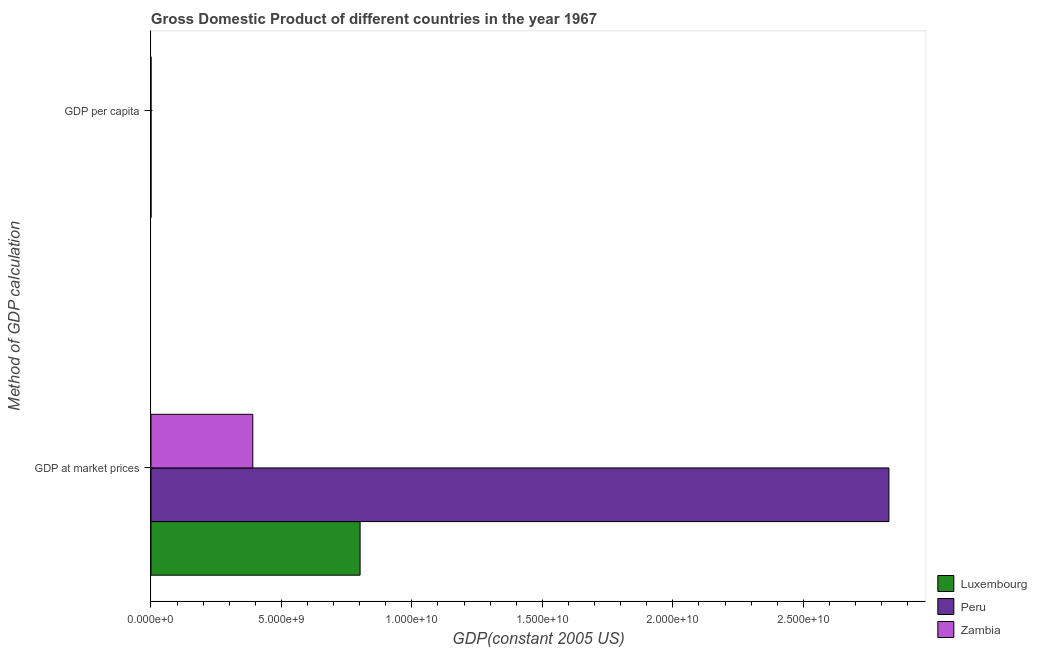How many different coloured bars are there?
Offer a very short reply. 3. How many bars are there on the 2nd tick from the bottom?
Provide a short and direct response. 3. What is the label of the 2nd group of bars from the top?
Give a very brief answer. GDP at market prices. What is the gdp at market prices in Zambia?
Keep it short and to the point. 3.90e+09. Across all countries, what is the maximum gdp per capita?
Provide a succinct answer. 2.39e+04. Across all countries, what is the minimum gdp at market prices?
Give a very brief answer. 3.90e+09. In which country was the gdp per capita maximum?
Give a very brief answer. Luxembourg. In which country was the gdp at market prices minimum?
Your answer should be very brief. Zambia. What is the total gdp per capita in the graph?
Your answer should be very brief. 2.73e+04. What is the difference between the gdp at market prices in Luxembourg and that in Peru?
Offer a very short reply. -2.03e+1. What is the difference between the gdp per capita in Zambia and the gdp at market prices in Luxembourg?
Make the answer very short. -8.01e+09. What is the average gdp at market prices per country?
Make the answer very short. 1.34e+1. What is the difference between the gdp per capita and gdp at market prices in Peru?
Ensure brevity in your answer.  -2.83e+1. In how many countries, is the gdp per capita greater than 11000000000 US$?
Make the answer very short. 0. What is the ratio of the gdp at market prices in Zambia to that in Luxembourg?
Your answer should be compact. 0.49. In how many countries, is the gdp per capita greater than the average gdp per capita taken over all countries?
Ensure brevity in your answer.  1. What does the 2nd bar from the top in GDP per capita represents?
Offer a very short reply. Peru. What does the 3rd bar from the bottom in GDP per capita represents?
Your response must be concise. Zambia. What is the difference between two consecutive major ticks on the X-axis?
Ensure brevity in your answer.  5.00e+09. Does the graph contain grids?
Provide a short and direct response. No. What is the title of the graph?
Ensure brevity in your answer.  Gross Domestic Product of different countries in the year 1967. What is the label or title of the X-axis?
Your answer should be very brief. GDP(constant 2005 US). What is the label or title of the Y-axis?
Your answer should be very brief. Method of GDP calculation. What is the GDP(constant 2005 US) of Luxembourg in GDP at market prices?
Keep it short and to the point. 8.01e+09. What is the GDP(constant 2005 US) of Peru in GDP at market prices?
Ensure brevity in your answer.  2.83e+1. What is the GDP(constant 2005 US) in Zambia in GDP at market prices?
Provide a short and direct response. 3.90e+09. What is the GDP(constant 2005 US) in Luxembourg in GDP per capita?
Provide a succinct answer. 2.39e+04. What is the GDP(constant 2005 US) of Peru in GDP per capita?
Ensure brevity in your answer.  2302.67. What is the GDP(constant 2005 US) of Zambia in GDP per capita?
Ensure brevity in your answer.  1028.98. Across all Method of GDP calculation, what is the maximum GDP(constant 2005 US) of Luxembourg?
Your answer should be compact. 8.01e+09. Across all Method of GDP calculation, what is the maximum GDP(constant 2005 US) of Peru?
Offer a very short reply. 2.83e+1. Across all Method of GDP calculation, what is the maximum GDP(constant 2005 US) of Zambia?
Your answer should be compact. 3.90e+09. Across all Method of GDP calculation, what is the minimum GDP(constant 2005 US) in Luxembourg?
Make the answer very short. 2.39e+04. Across all Method of GDP calculation, what is the minimum GDP(constant 2005 US) in Peru?
Offer a terse response. 2302.67. Across all Method of GDP calculation, what is the minimum GDP(constant 2005 US) in Zambia?
Your answer should be compact. 1028.98. What is the total GDP(constant 2005 US) in Luxembourg in the graph?
Give a very brief answer. 8.01e+09. What is the total GDP(constant 2005 US) of Peru in the graph?
Your answer should be very brief. 2.83e+1. What is the total GDP(constant 2005 US) in Zambia in the graph?
Offer a terse response. 3.90e+09. What is the difference between the GDP(constant 2005 US) of Luxembourg in GDP at market prices and that in GDP per capita?
Your response must be concise. 8.01e+09. What is the difference between the GDP(constant 2005 US) in Peru in GDP at market prices and that in GDP per capita?
Your response must be concise. 2.83e+1. What is the difference between the GDP(constant 2005 US) of Zambia in GDP at market prices and that in GDP per capita?
Your response must be concise. 3.90e+09. What is the difference between the GDP(constant 2005 US) in Luxembourg in GDP at market prices and the GDP(constant 2005 US) in Peru in GDP per capita?
Keep it short and to the point. 8.01e+09. What is the difference between the GDP(constant 2005 US) in Luxembourg in GDP at market prices and the GDP(constant 2005 US) in Zambia in GDP per capita?
Keep it short and to the point. 8.01e+09. What is the difference between the GDP(constant 2005 US) of Peru in GDP at market prices and the GDP(constant 2005 US) of Zambia in GDP per capita?
Offer a terse response. 2.83e+1. What is the average GDP(constant 2005 US) of Luxembourg per Method of GDP calculation?
Your answer should be very brief. 4.01e+09. What is the average GDP(constant 2005 US) of Peru per Method of GDP calculation?
Your response must be concise. 1.41e+1. What is the average GDP(constant 2005 US) in Zambia per Method of GDP calculation?
Offer a terse response. 1.95e+09. What is the difference between the GDP(constant 2005 US) in Luxembourg and GDP(constant 2005 US) in Peru in GDP at market prices?
Your response must be concise. -2.03e+1. What is the difference between the GDP(constant 2005 US) in Luxembourg and GDP(constant 2005 US) in Zambia in GDP at market prices?
Provide a succinct answer. 4.11e+09. What is the difference between the GDP(constant 2005 US) of Peru and GDP(constant 2005 US) of Zambia in GDP at market prices?
Provide a short and direct response. 2.44e+1. What is the difference between the GDP(constant 2005 US) in Luxembourg and GDP(constant 2005 US) in Peru in GDP per capita?
Ensure brevity in your answer.  2.16e+04. What is the difference between the GDP(constant 2005 US) in Luxembourg and GDP(constant 2005 US) in Zambia in GDP per capita?
Provide a short and direct response. 2.29e+04. What is the difference between the GDP(constant 2005 US) in Peru and GDP(constant 2005 US) in Zambia in GDP per capita?
Offer a very short reply. 1273.7. What is the ratio of the GDP(constant 2005 US) in Luxembourg in GDP at market prices to that in GDP per capita?
Provide a short and direct response. 3.35e+05. What is the ratio of the GDP(constant 2005 US) of Peru in GDP at market prices to that in GDP per capita?
Provide a short and direct response. 1.23e+07. What is the ratio of the GDP(constant 2005 US) in Zambia in GDP at market prices to that in GDP per capita?
Ensure brevity in your answer.  3.79e+06. What is the difference between the highest and the second highest GDP(constant 2005 US) of Luxembourg?
Make the answer very short. 8.01e+09. What is the difference between the highest and the second highest GDP(constant 2005 US) of Peru?
Offer a terse response. 2.83e+1. What is the difference between the highest and the second highest GDP(constant 2005 US) in Zambia?
Ensure brevity in your answer.  3.90e+09. What is the difference between the highest and the lowest GDP(constant 2005 US) in Luxembourg?
Give a very brief answer. 8.01e+09. What is the difference between the highest and the lowest GDP(constant 2005 US) of Peru?
Offer a terse response. 2.83e+1. What is the difference between the highest and the lowest GDP(constant 2005 US) in Zambia?
Keep it short and to the point. 3.90e+09. 